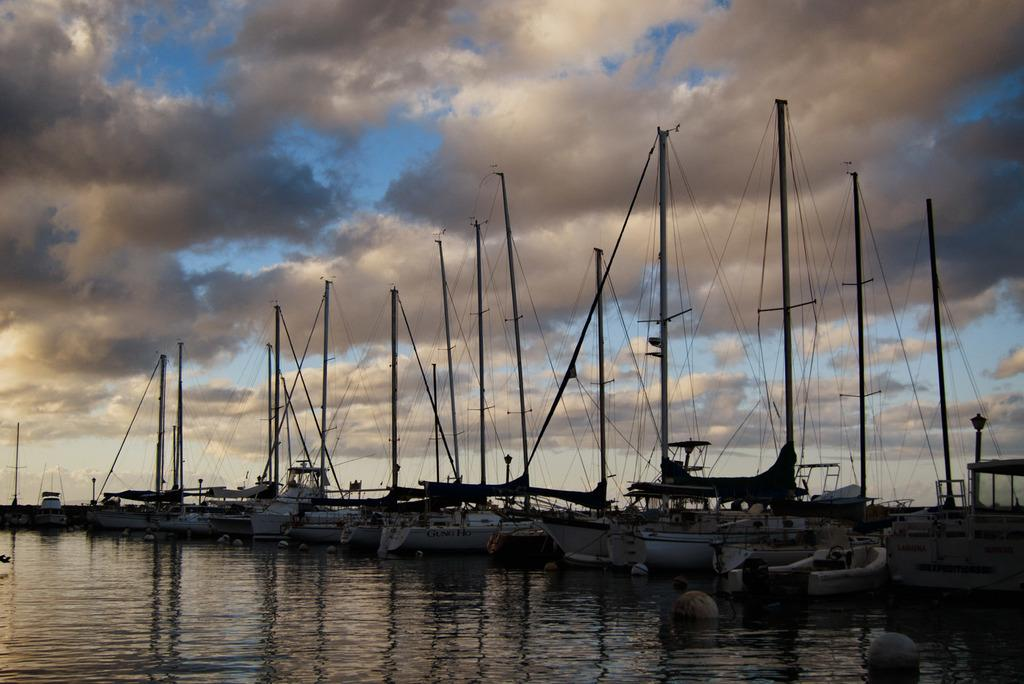What is the main subject of the image? The main subject of the image is ships. Where are the ships located? The ships are on the water. What can be seen in the background of the image? The background of the image includes the sky. How would you describe the color of the sky in the image? The sky is a combination of white and blue colors. Can you see a rose growing near the ships in the image? No, there is no rose present in the image. What type of mint is being used as a garnish on the ships? There is no mint or any food items present in the image; it features ships on the water. 